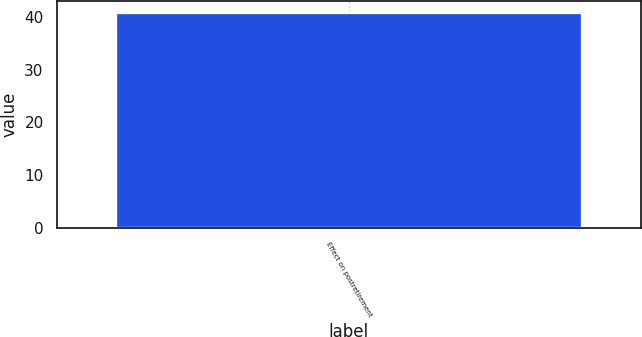Convert chart. <chart><loc_0><loc_0><loc_500><loc_500><bar_chart><fcel>Effect on postretirement<nl><fcel>41<nl></chart> 